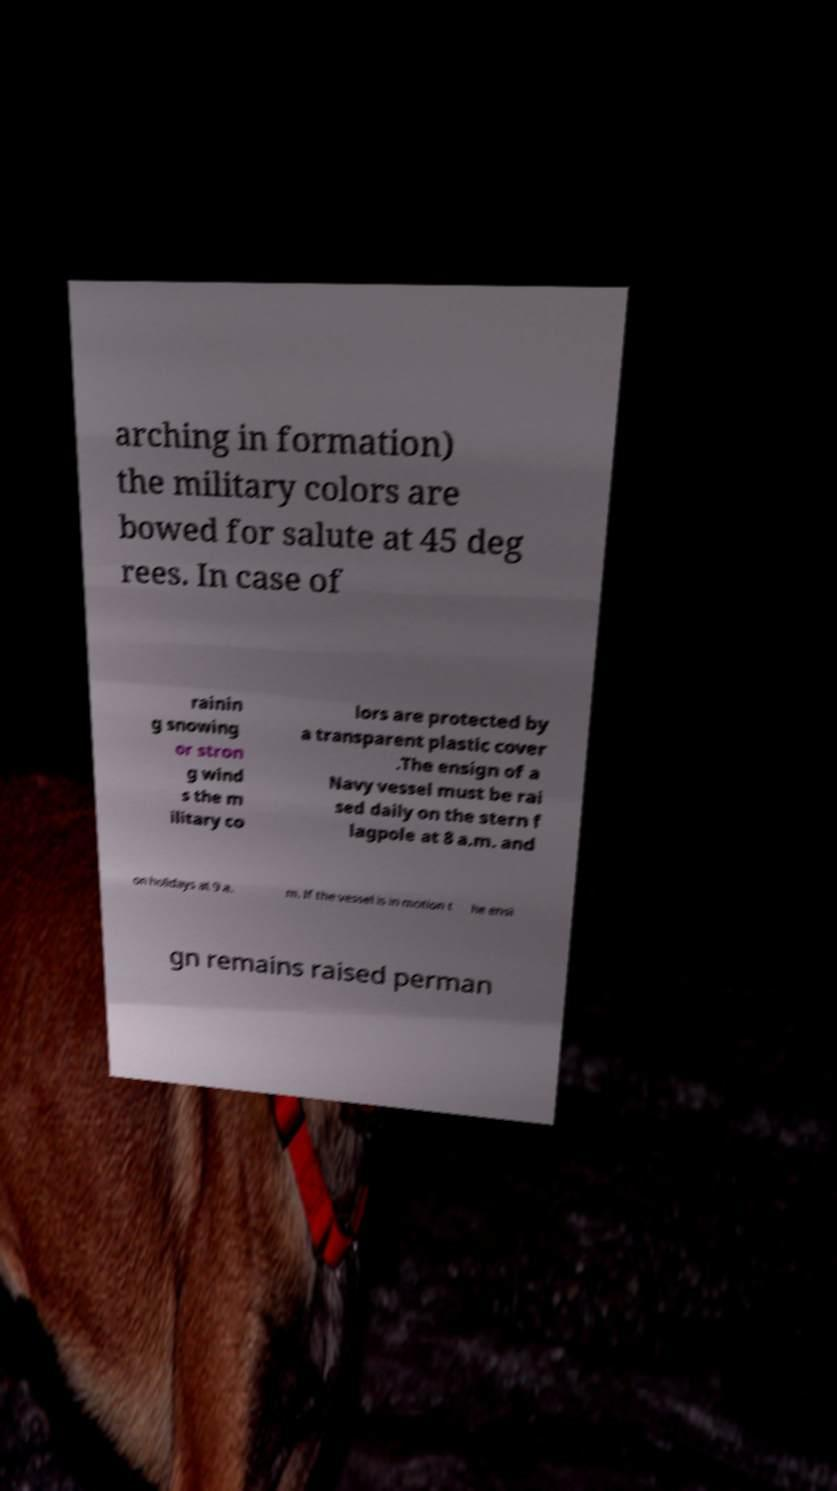I need the written content from this picture converted into text. Can you do that? arching in formation) the military colors are bowed for salute at 45 deg rees. In case of rainin g snowing or stron g wind s the m ilitary co lors are protected by a transparent plastic cover .The ensign of a Navy vessel must be rai sed daily on the stern f lagpole at 8 a.m. and on holidays at 9 a. m. If the vessel is in motion t he ensi gn remains raised perman 